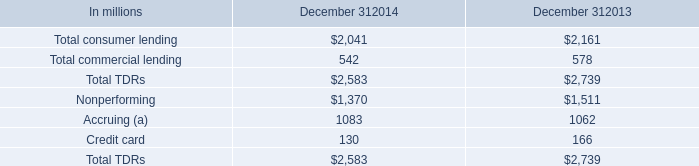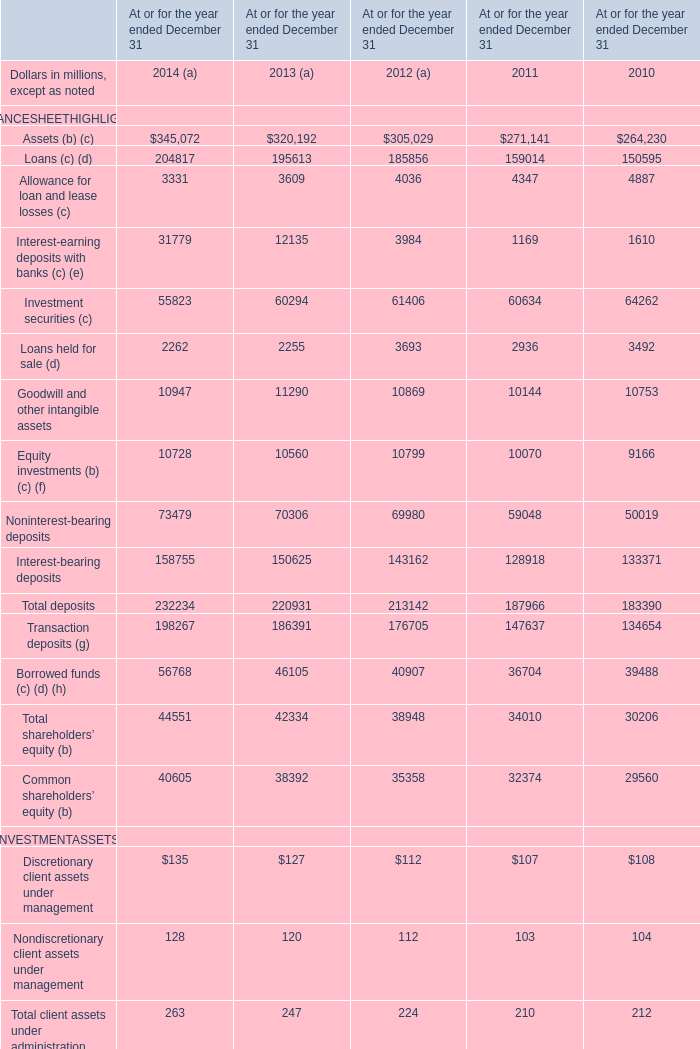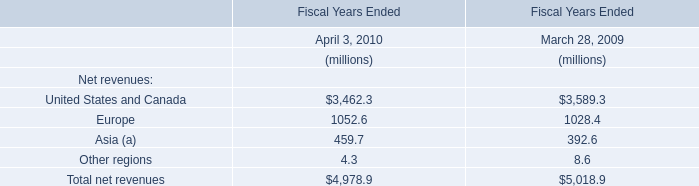what is the highest total amount of Assets (b) (c) in 2014 and 2013 ?? 
Computations: (345072 + 320192)
Answer: 665264.0. 